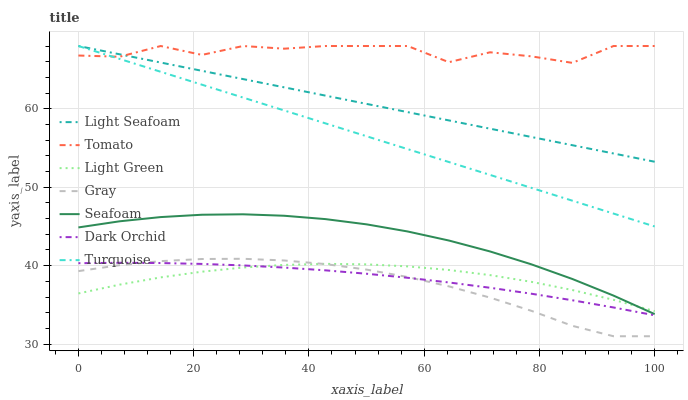Does Turquoise have the minimum area under the curve?
Answer yes or no. No. Does Turquoise have the maximum area under the curve?
Answer yes or no. No. Is Gray the smoothest?
Answer yes or no. No. Is Gray the roughest?
Answer yes or no. No. Does Turquoise have the lowest value?
Answer yes or no. No. Does Gray have the highest value?
Answer yes or no. No. Is Light Green less than Turquoise?
Answer yes or no. Yes. Is Tomato greater than Light Green?
Answer yes or no. Yes. Does Light Green intersect Turquoise?
Answer yes or no. No. 